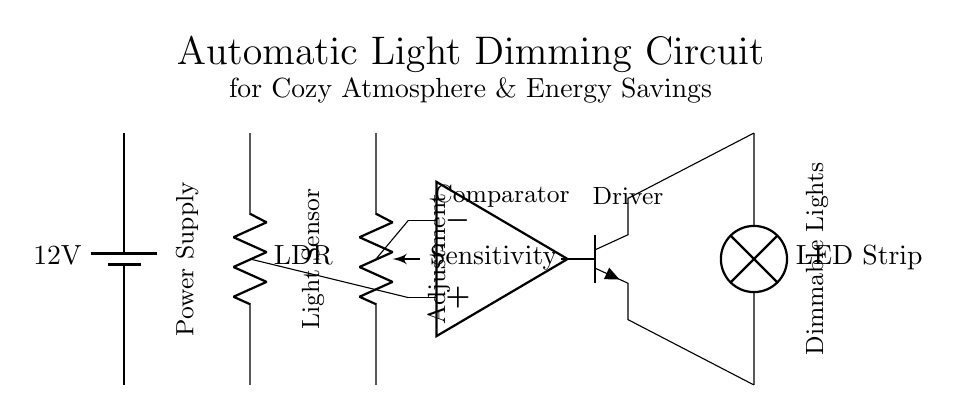What is the power supply voltage in this circuit? The circuit diagram shows a battery labeled with a voltage of 12 volts, which indicates the power supply voltage for the entire circuit.
Answer: 12 volts What component is used as a light sensor? In the circuit, there is a component labeled LDR indicated as the light sensor. LDR stands for Light Dependent Resistor, which changes its resistance based on light intensity.
Answer: LDR How many main components are visible in the circuit? The circuit contains six main components: a battery, light sensor, potentiometer, operational amplifier, transistor, and an LED strip. This can be counted visually from the diagram.
Answer: Six What does the potentiometer control? The potentiometer labeled as "Sensitivity" adjusts the sensitivity of the light sensor (LDR) in the circuit, influencing how the circuit reacts to different light levels.
Answer: Sensitivity Which component acts as a switch in this circuit? The transistor, specifically marked as NPN, acts as a switch that controls the power to the LED strip based on the output from the operational amplifier, which compares light levels.
Answer: Transistor What is the function of the operational amplifier in this circuit? The operational amplifier in this circuit compares the voltage from the light sensor (LDR) and the reference voltage from the potentiometer, determining when to turn the LED strip on or off based on the ambient light level.
Answer: Comparator What type of lights are being controlled in this circuit? The circuit diagram shows an LED strip labeled as the light output component, indicating that it specifically controls LED lighting for dimming.
Answer: LED strip 